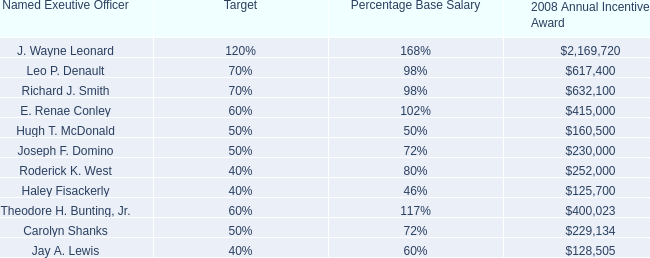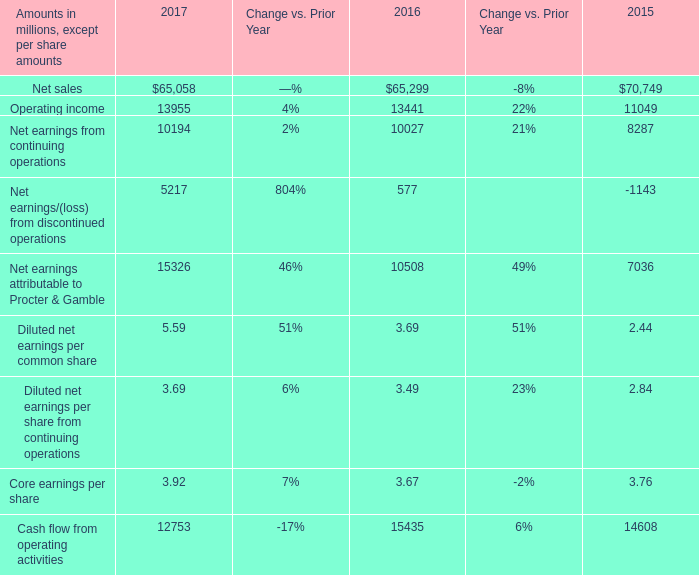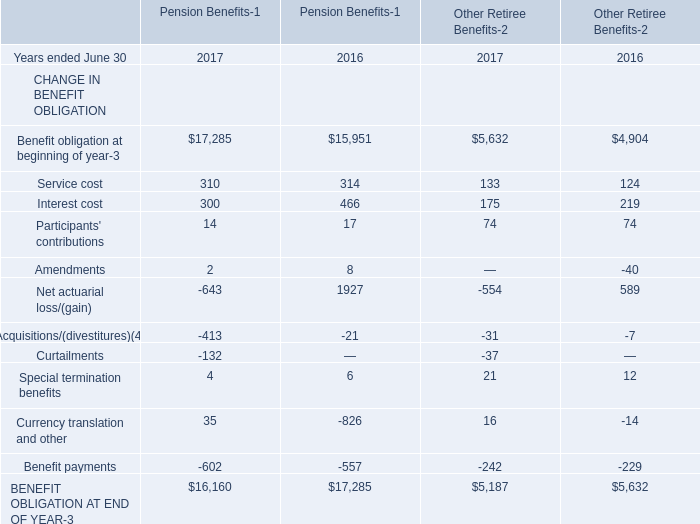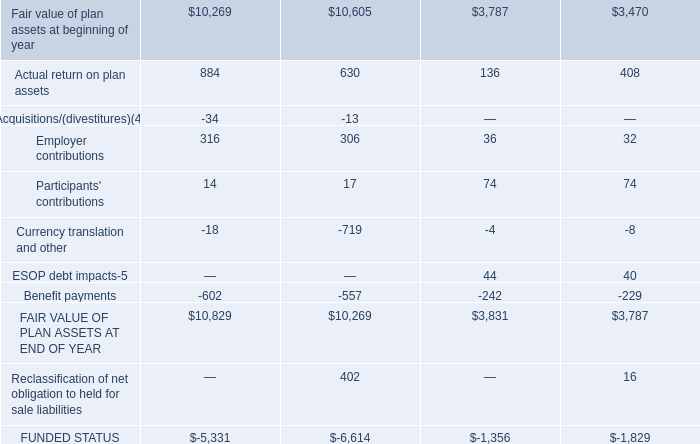What is the average amount of Fair value of plan assets at beginning of year, and Jay A. Lewis of 2008 Annual Incentive Award ? 
Computations: ((10269.0 + 128505.0) / 2)
Answer: 69387.0. 